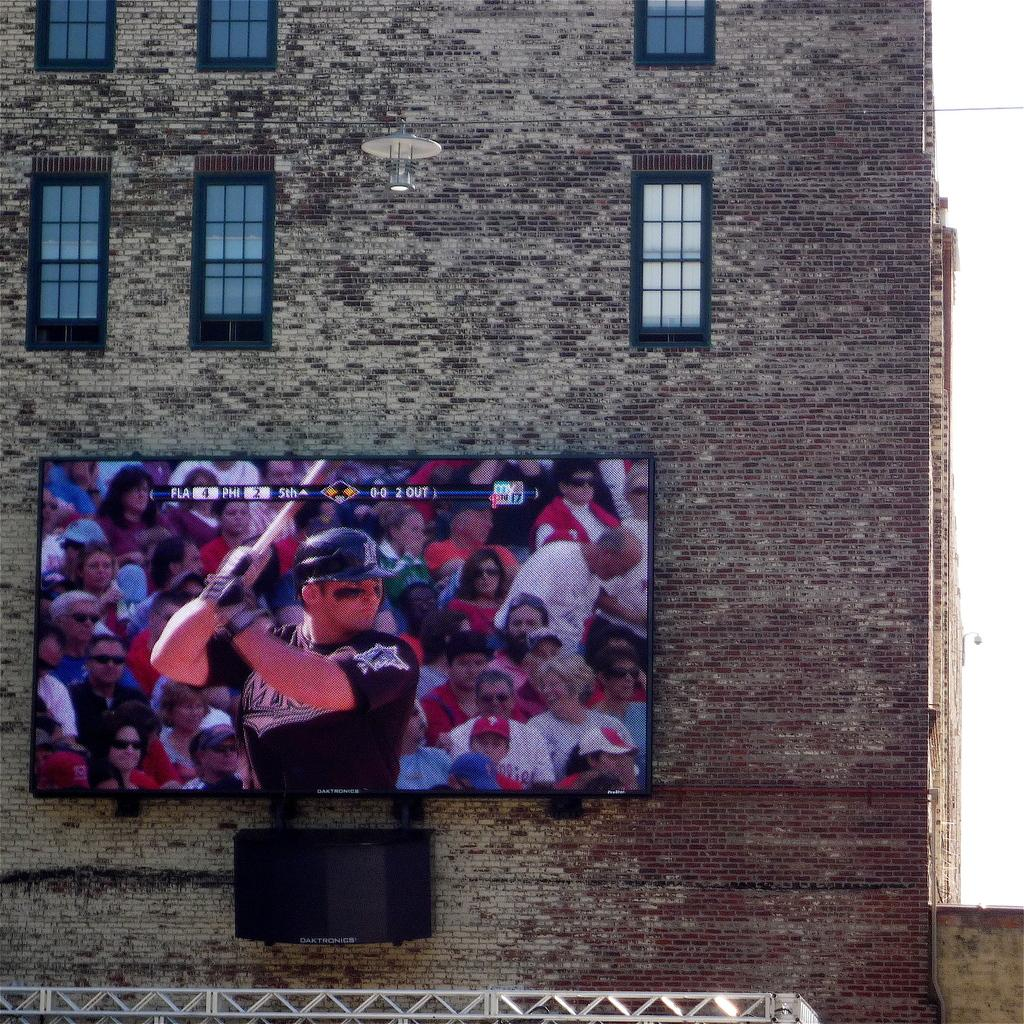What structure is visible in the image? There is a building in the image. What is placed on the wall of the building? There is a screen placed on the wall of the building. How can natural light enter the building? There are windows in the building. What is located at the bottom of the image? There is a rod at the bottom of the image. What feature is associated with the rod? There are lights associated with the rod. What type of cracker is being used to prop open the door in the image? There is no door or cracker present in the image. 